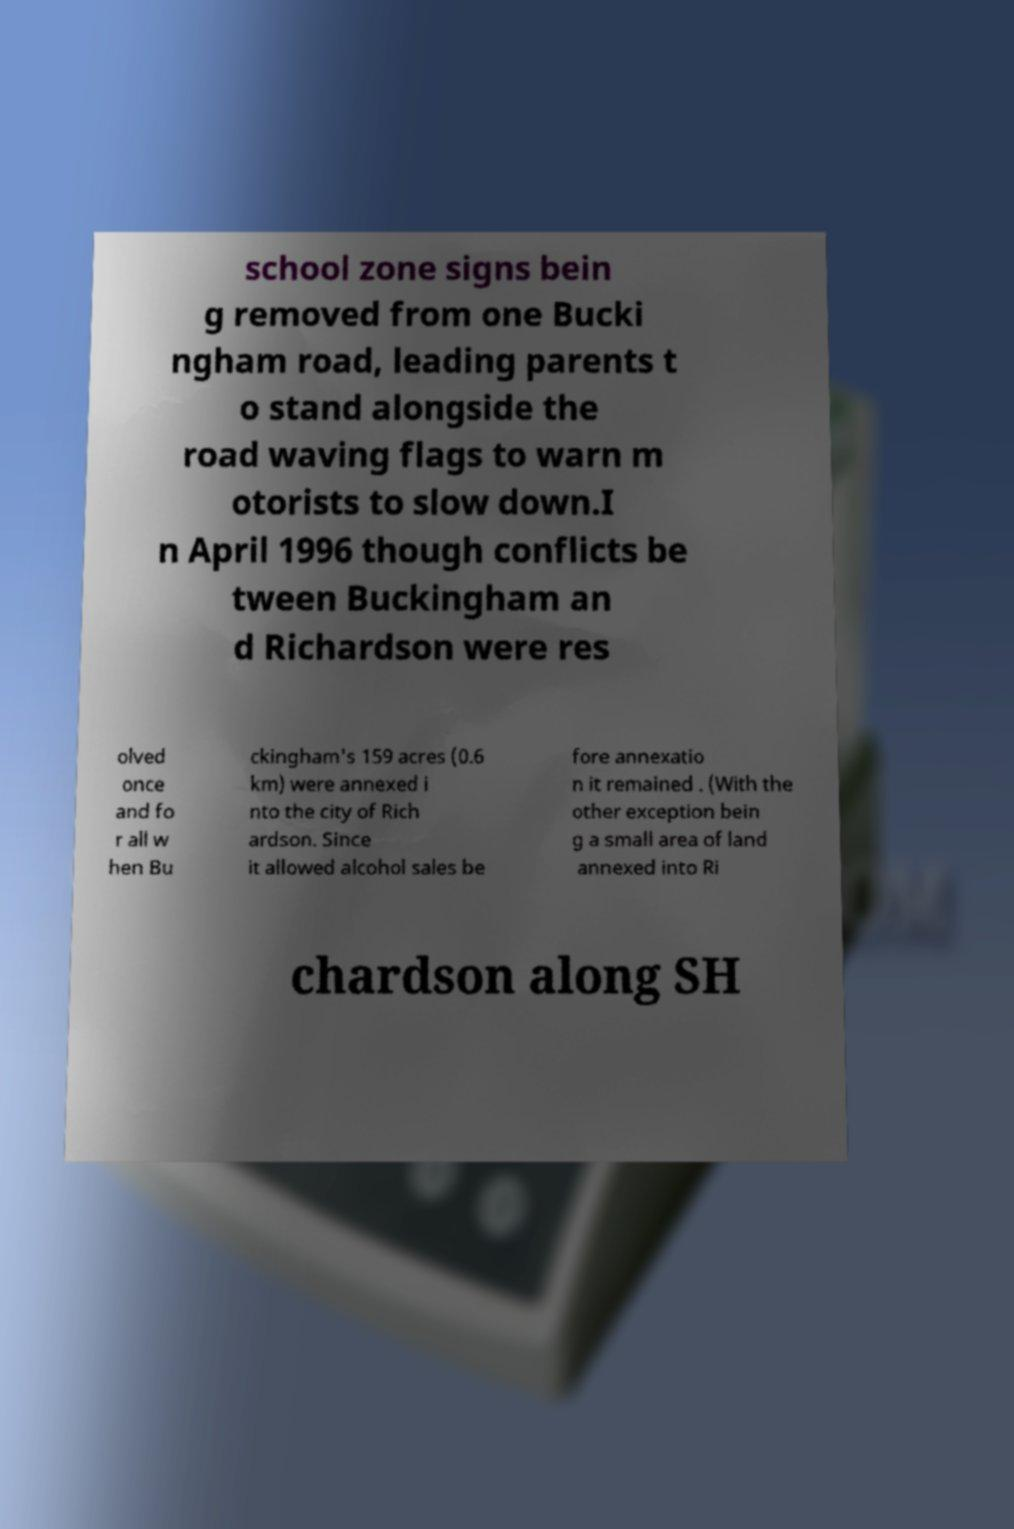There's text embedded in this image that I need extracted. Can you transcribe it verbatim? school zone signs bein g removed from one Bucki ngham road, leading parents t o stand alongside the road waving flags to warn m otorists to slow down.I n April 1996 though conflicts be tween Buckingham an d Richardson were res olved once and fo r all w hen Bu ckingham's 159 acres (0.6 km) were annexed i nto the city of Rich ardson. Since it allowed alcohol sales be fore annexatio n it remained . (With the other exception bein g a small area of land annexed into Ri chardson along SH 